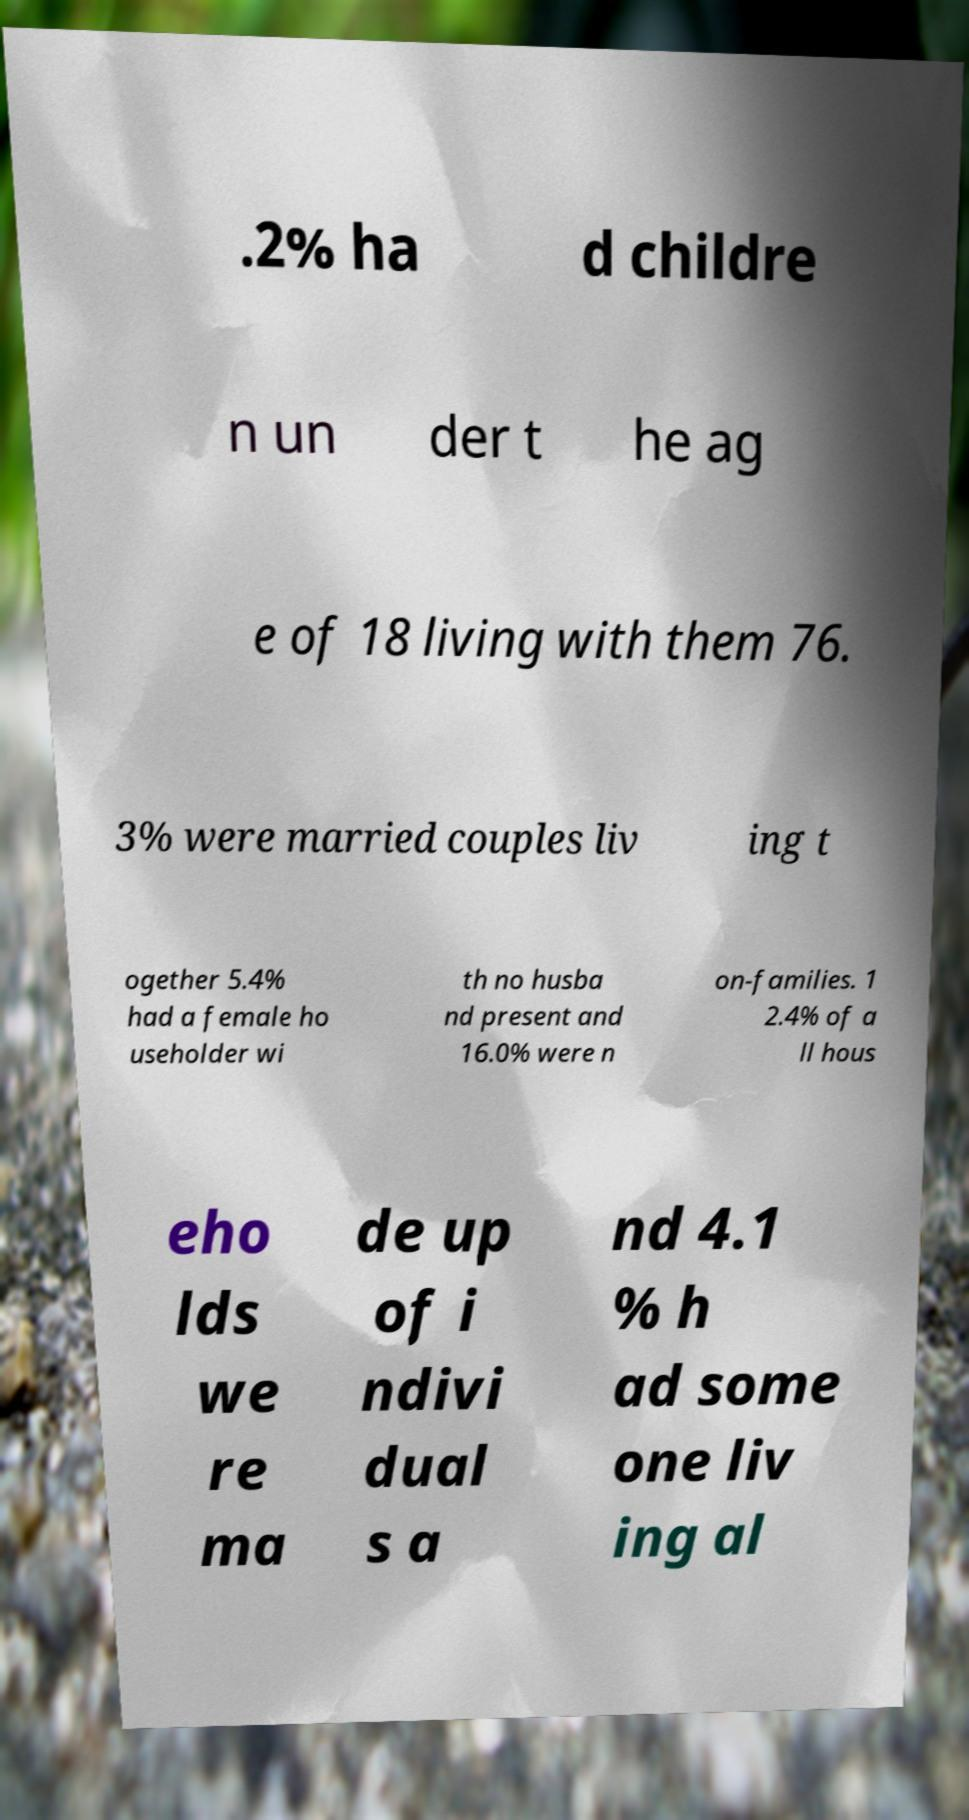I need the written content from this picture converted into text. Can you do that? .2% ha d childre n un der t he ag e of 18 living with them 76. 3% were married couples liv ing t ogether 5.4% had a female ho useholder wi th no husba nd present and 16.0% were n on-families. 1 2.4% of a ll hous eho lds we re ma de up of i ndivi dual s a nd 4.1 % h ad some one liv ing al 